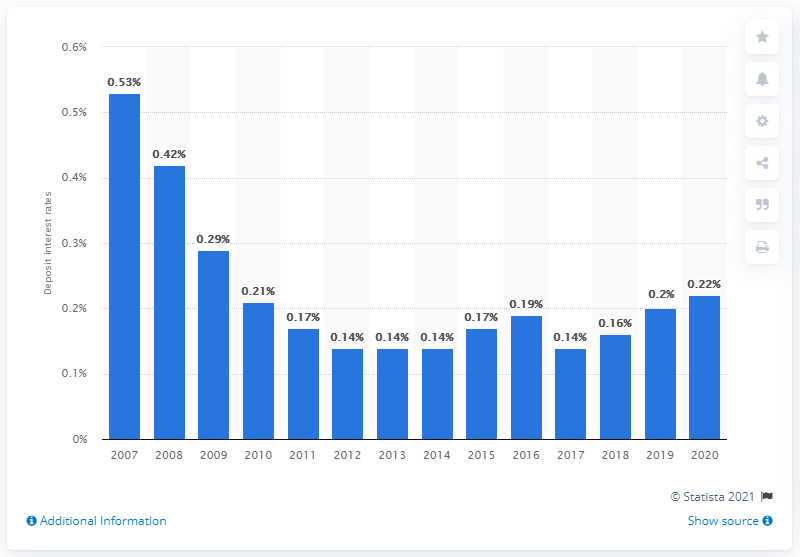Specify some key components in this picture. In 2019, the deposit interest rate by banks in Singapore was 0.22%. 